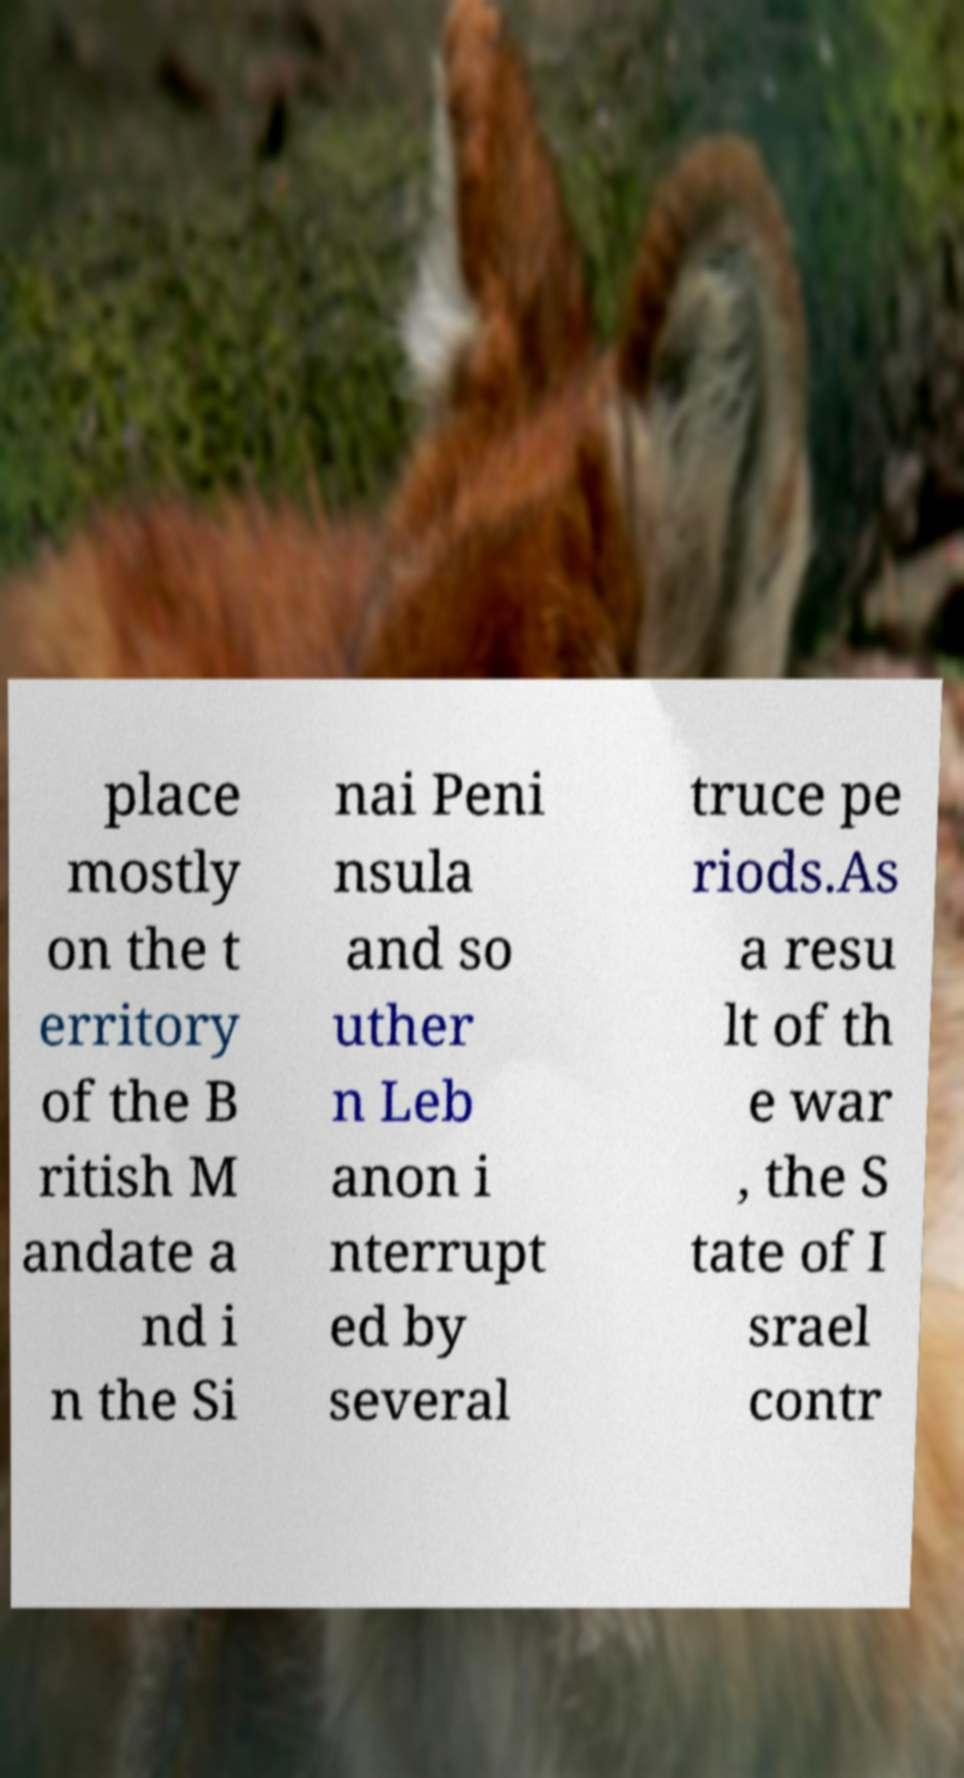For documentation purposes, I need the text within this image transcribed. Could you provide that? place mostly on the t erritory of the B ritish M andate a nd i n the Si nai Peni nsula and so uther n Leb anon i nterrupt ed by several truce pe riods.As a resu lt of th e war , the S tate of I srael contr 